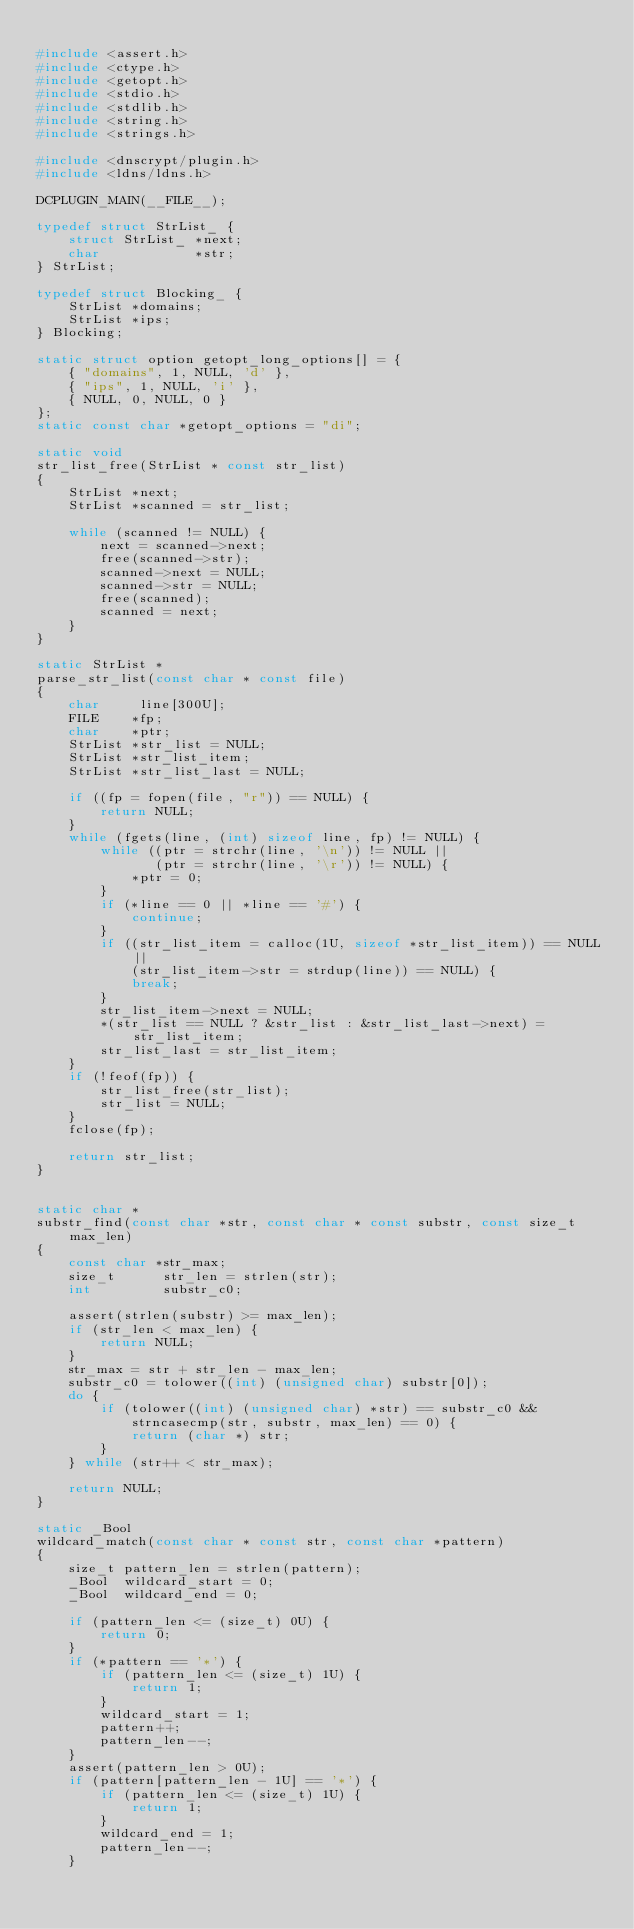Convert code to text. <code><loc_0><loc_0><loc_500><loc_500><_C_>
#include <assert.h>
#include <ctype.h>
#include <getopt.h>
#include <stdio.h>
#include <stdlib.h>
#include <string.h>
#include <strings.h>

#include <dnscrypt/plugin.h>
#include <ldns/ldns.h>

DCPLUGIN_MAIN(__FILE__);

typedef struct StrList_ {
    struct StrList_ *next;
    char            *str;
} StrList;

typedef struct Blocking_ {
    StrList *domains;
    StrList *ips;
} Blocking;

static struct option getopt_long_options[] = {
    { "domains", 1, NULL, 'd' },
    { "ips", 1, NULL, 'i' },
    { NULL, 0, NULL, 0 }
};
static const char *getopt_options = "di";

static void
str_list_free(StrList * const str_list)
{
    StrList *next;
    StrList *scanned = str_list;

    while (scanned != NULL) {
        next = scanned->next;
        free(scanned->str);
        scanned->next = NULL;
        scanned->str = NULL;
        free(scanned);
        scanned = next;
    }
}

static StrList *
parse_str_list(const char * const file)
{
    char     line[300U];
    FILE    *fp;
    char    *ptr;
    StrList *str_list = NULL;
    StrList *str_list_item;
    StrList *str_list_last = NULL;

    if ((fp = fopen(file, "r")) == NULL) {
        return NULL;
    }
    while (fgets(line, (int) sizeof line, fp) != NULL) {
        while ((ptr = strchr(line, '\n')) != NULL ||
               (ptr = strchr(line, '\r')) != NULL) {
            *ptr = 0;
        }
        if (*line == 0 || *line == '#') {
            continue;
        }
        if ((str_list_item = calloc(1U, sizeof *str_list_item)) == NULL ||
            (str_list_item->str = strdup(line)) == NULL) {
            break;
        }
        str_list_item->next = NULL;
        *(str_list == NULL ? &str_list : &str_list_last->next) = str_list_item;
        str_list_last = str_list_item;
    }
    if (!feof(fp)) {
        str_list_free(str_list);
        str_list = NULL;
    }
    fclose(fp);

    return str_list;
}


static char *
substr_find(const char *str, const char * const substr, const size_t max_len)
{
    const char *str_max;
    size_t      str_len = strlen(str);
    int         substr_c0;

    assert(strlen(substr) >= max_len);
    if (str_len < max_len) {
        return NULL;
    }
    str_max = str + str_len - max_len;
    substr_c0 = tolower((int) (unsigned char) substr[0]);
    do {
        if (tolower((int) (unsigned char) *str) == substr_c0 &&
            strncasecmp(str, substr, max_len) == 0) {
            return (char *) str;
        }
    } while (str++ < str_max);

    return NULL;
}

static _Bool
wildcard_match(const char * const str, const char *pattern)
{
    size_t pattern_len = strlen(pattern);
    _Bool  wildcard_start = 0;
    _Bool  wildcard_end = 0;

    if (pattern_len <= (size_t) 0U) {
        return 0;
    }
    if (*pattern == '*') {
        if (pattern_len <= (size_t) 1U) {
            return 1;
        }
        wildcard_start = 1;
        pattern++;
        pattern_len--;
    }
    assert(pattern_len > 0U);
    if (pattern[pattern_len - 1U] == '*') {
        if (pattern_len <= (size_t) 1U) {
            return 1;
        }
        wildcard_end = 1;
        pattern_len--;
    }</code> 